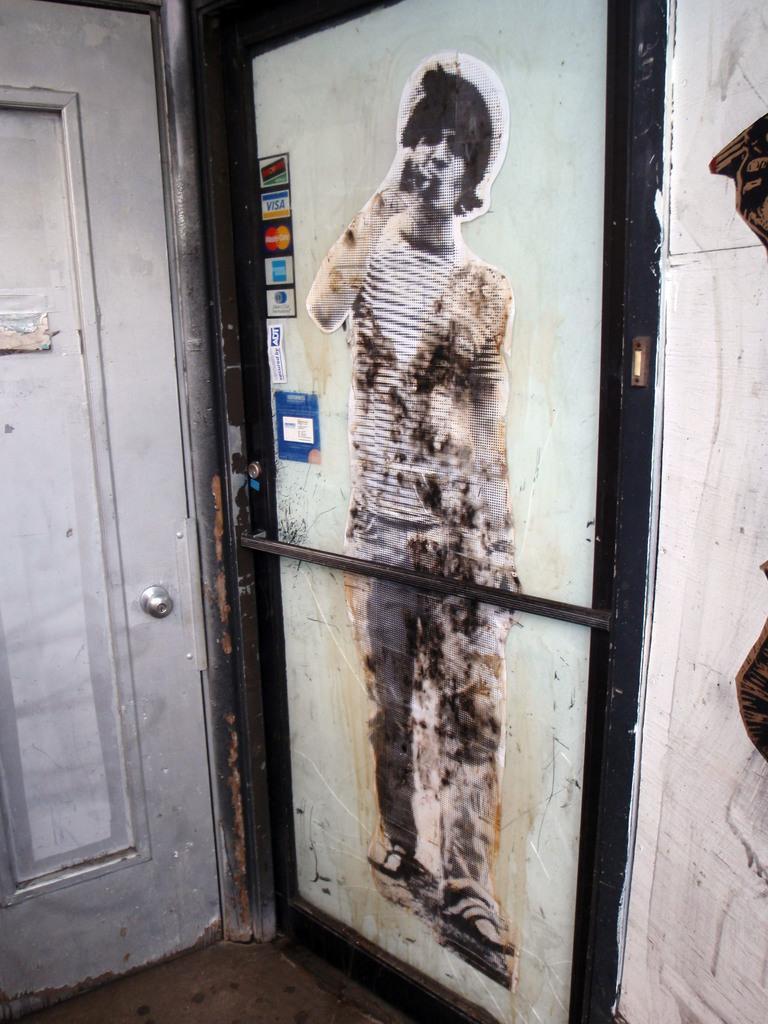In one or two sentences, can you explain what this image depicts? In this picture we can see posters on doors, rod, door handle and the wall. 